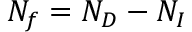Convert formula to latex. <formula><loc_0><loc_0><loc_500><loc_500>N _ { f } = N _ { D } - N _ { I }</formula> 